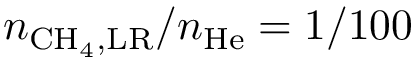<formula> <loc_0><loc_0><loc_500><loc_500>n _ { C H _ { 4 } , L R } / n _ { H e } = 1 / 1 0 0</formula> 